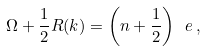<formula> <loc_0><loc_0><loc_500><loc_500>\Omega + \frac { 1 } { 2 } R ( k ) = \left ( n + \frac { 1 } { 2 } \right ) \ e \, ,</formula> 